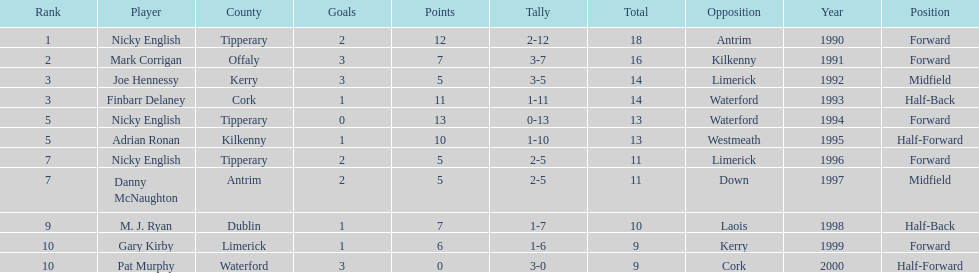Joe hennessy and finbarr delaney both scored how many points? 14. 